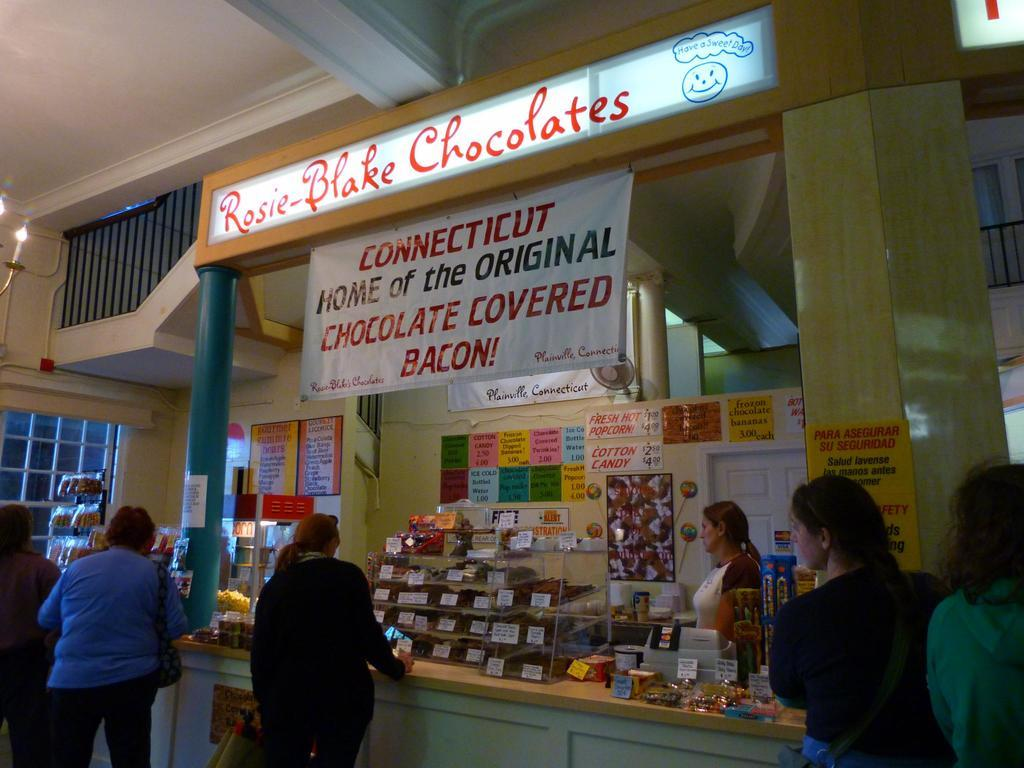Who is present in the image? There are people in the image. What are the people doing in the image? The people are buying products in the image. Where is the scene taking place? The setting is a shop. Can you see any hope in the image? The concept of hope is not a tangible object or element that can be seen in the image. The image depicts people buying products in a shop. 